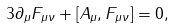Convert formula to latex. <formula><loc_0><loc_0><loc_500><loc_500>3 \partial _ { \mu } F _ { \mu \nu } + [ A _ { \mu } , F _ { \mu \nu } ] = 0 ,</formula> 